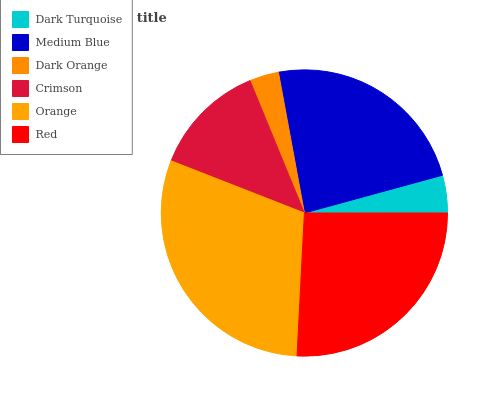Is Dark Orange the minimum?
Answer yes or no. Yes. Is Orange the maximum?
Answer yes or no. Yes. Is Medium Blue the minimum?
Answer yes or no. No. Is Medium Blue the maximum?
Answer yes or no. No. Is Medium Blue greater than Dark Turquoise?
Answer yes or no. Yes. Is Dark Turquoise less than Medium Blue?
Answer yes or no. Yes. Is Dark Turquoise greater than Medium Blue?
Answer yes or no. No. Is Medium Blue less than Dark Turquoise?
Answer yes or no. No. Is Medium Blue the high median?
Answer yes or no. Yes. Is Crimson the low median?
Answer yes or no. Yes. Is Orange the high median?
Answer yes or no. No. Is Red the low median?
Answer yes or no. No. 